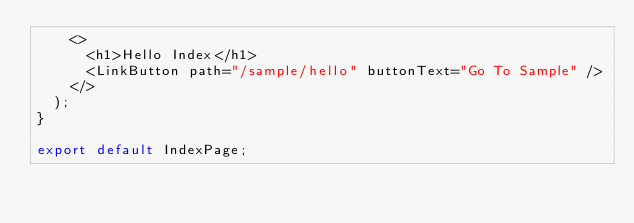<code> <loc_0><loc_0><loc_500><loc_500><_TypeScript_>    <>
      <h1>Hello Index</h1>
      <LinkButton path="/sample/hello" buttonText="Go To Sample" />
    </>
  );
}

export default IndexPage;</code> 